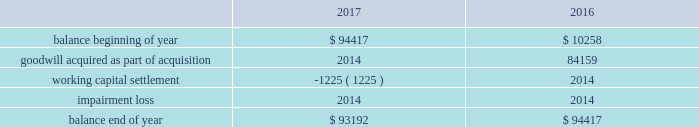Note 4 - goodwill and other intangible assets : goodwill the company had approximately $ 93.2 million and $ 94.4 million of goodwill at december 30 , 2017 and december 31 , 2016 , respectively .
The changes in the carrying amount of goodwill for the years ended december 30 , 2017 and december 31 , 2016 are as follows ( in thousands ) : .
Goodwill is allocated to each identified reporting unit , which is defined as an operating segment or one level below the operating segment .
Goodwill is not amortized , but is evaluated for impairment annually and whenever events or changes in circumstances indicate the carrying value of goodwill may not be recoverable .
The company completes its impairment evaluation by performing valuation analyses and considering other publicly available market information , as appropriate .
The test used to identify the potential for goodwill impairment compares the fair value of a reporting unit with its carrying value .
An impairment charge would be recorded to the company 2019s operations for the amount , if any , in which the carrying value exceeds the fair value .
In the fourth quarter of fiscal 2017 , the company completed its annual impairment testing of goodwill and no impairment was identified .
The company determined that the fair value of each reporting unit ( including goodwill ) was in excess of the carrying value of the respective reporting unit .
In reaching this conclusion , the fair value of each reporting unit was determined based on either a market or an income approach .
Under the market approach , the fair value is based on observed market data .
Other intangible assets the company had approximately $ 31.3 million of intangible assets other than goodwill at december 30 , 2017 and december 31 , 2016 .
The intangible asset balance represents the estimated fair value of the petsense tradename , which is not subject to amortization as it has an indefinite useful life on the basis that it is expected to contribute cash flows beyond the foreseeable horizon .
With respect to intangible assets , we evaluate for impairment annually and whenever events or changes in circumstances indicate that the carrying value may not be recoverable .
We recognize an impairment loss only if the carrying amount is not recoverable through its discounted cash flows and measure the impairment loss based on the difference between the carrying value and fair value .
In the fourth quarter of fiscal 2017 , the company completed its annual impairment testing of intangible assets and no impairment was identified. .
What percent of the 2017 end goodwill balance is the goodwill from the acquisition? 
Computations: (84159 / 94417)
Answer: 0.89135. 